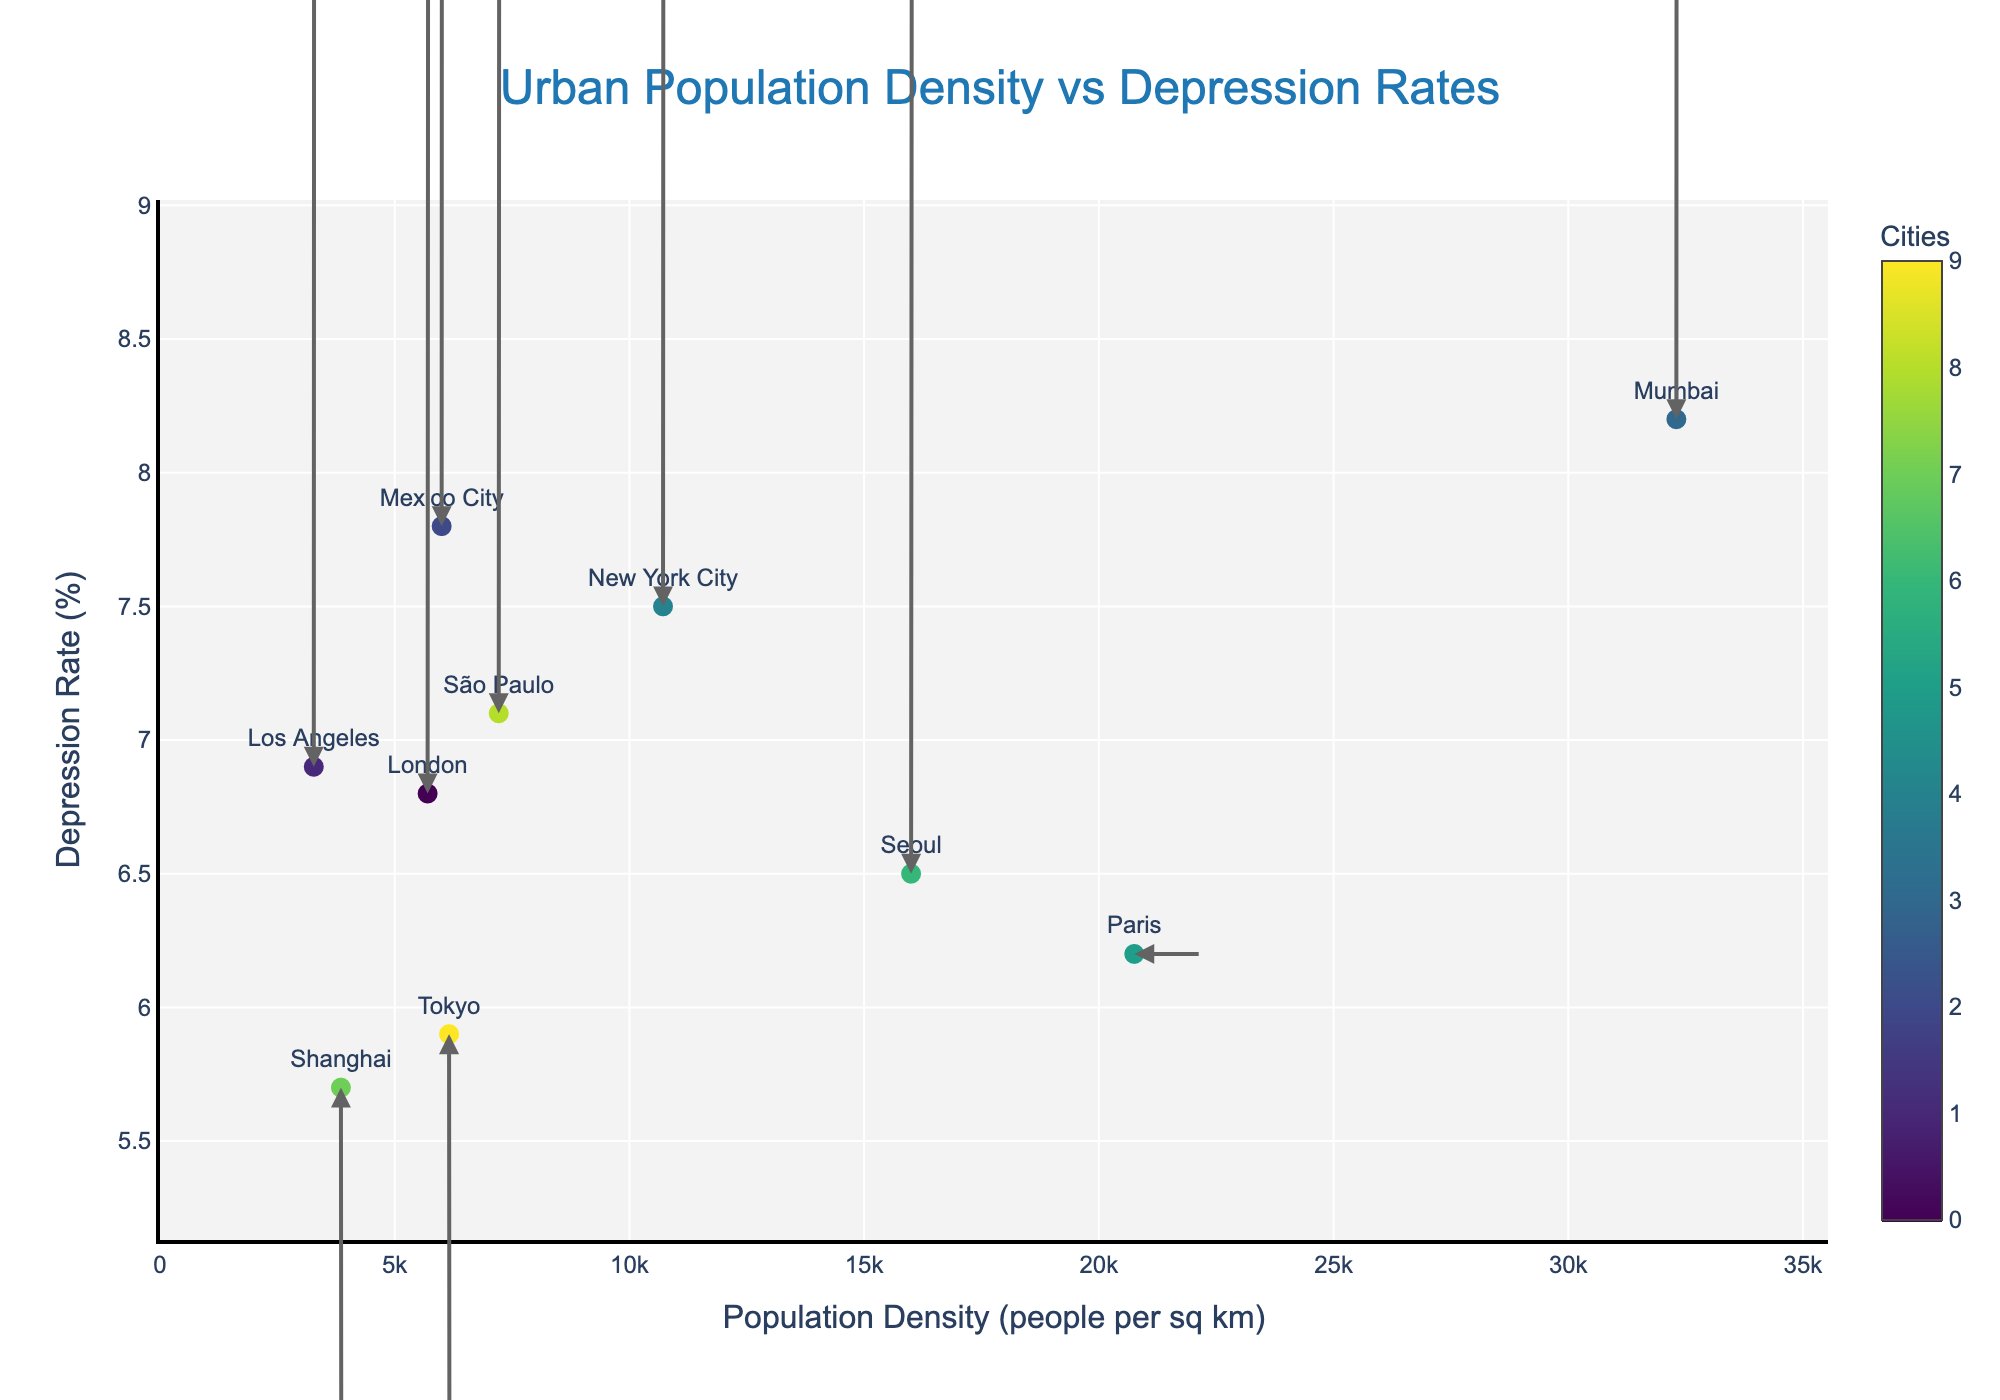What is the title of the plot? The title of the plot is displayed at the top center of the figure. It reads "Urban Population Density vs Depression Rates".
Answer: Urban Population Density vs Depression Rates What does the x-axis represent? The x-axis title is displayed along the horizontal axis and it reads "Population Density (people per sq km)".
Answer: Population Density (people per sq km) Which city has the highest depression rate? By examining the y-axis (Depression Rate %) and identifying the marker at the highest point, Mumbai has the highest depression rate at 8.2%.
Answer: Mumbai How many cities are represented in the plot? There are individual markers labeled with city names, and counting these labels reveals there are 10 cities represented.
Answer: 10 Which city shows a decrease in depression rate over time? By observing the direction of the arrows, Tokyo and Shanghai have arrows pointing downward (negative y direction), indicating a decrease in depression rate.
Answer: Tokyo and Shanghai Between New York City and São Paulo, which city has a higher population density? Comparing the horizontal (x-axis) positions of the markers for New York City and São Paulo, New York City (10716 people per sq km) has a higher population density than São Paulo (7216 people per sq km).
Answer: New York City Which city shows the largest increase in both population density and depression rate? Examining the length and direction of the arrows relative to the markers, Mumbai shows the largest arrow pointing upwards and rightwards, indicating the largest increase in both population density and depression rate.
Answer: Mumbai Which two cities have approximately the same population density but different depression rates? London and Mexico City have close x-axis positions (population density near 6000), but London has a depression rate of 6.8%, while Mexico City has a rate of 7.8%.
Answer: London and Mexico City What is the average depression rate of all cities? Summing up depression rates (7.5 + 5.9 + 6.8 + 8.2 + 6.5 + 7.8 + 6.2 + 7.1 + 5.7 + 6.9 = 68.6) and dividing by the number of cities (10) gives the average as 68.6/10 = 6.86.
Answer: 6.86 